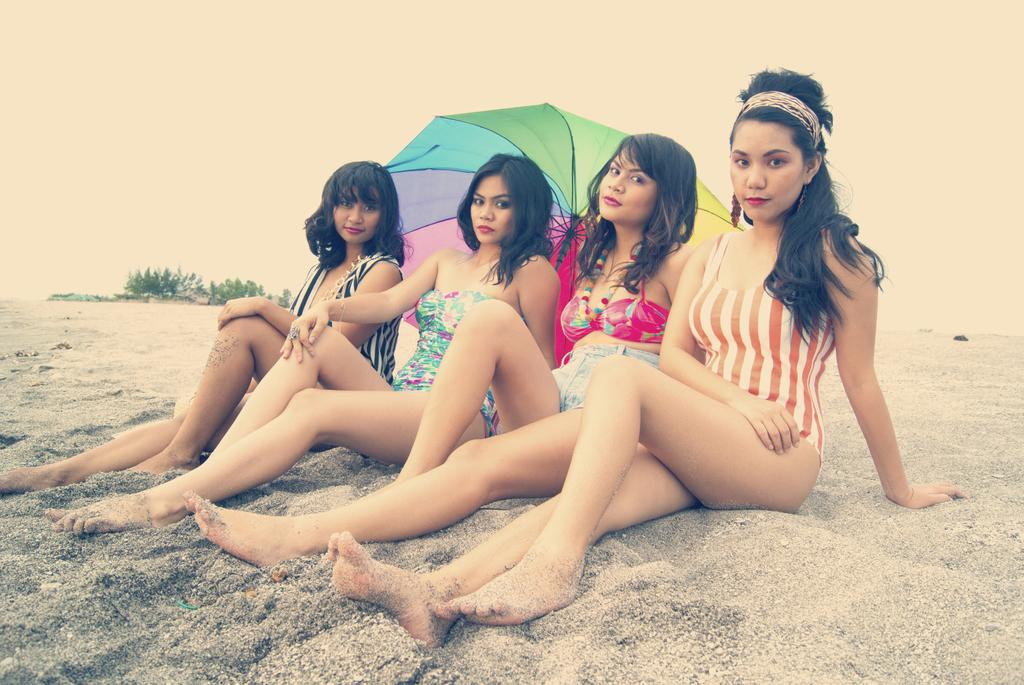How many women are sitting on the sand in the image? There are four women sitting on the sand in the image. What object can be seen providing shade in the image? There is an umbrella in the image. What can be seen in the background of the image? Planets and the sky are visible in the background of the image. What type of chicken is being used as a beach towel in the image? There is no chicken present in the image, and therefore it cannot be used as a beach towel. 